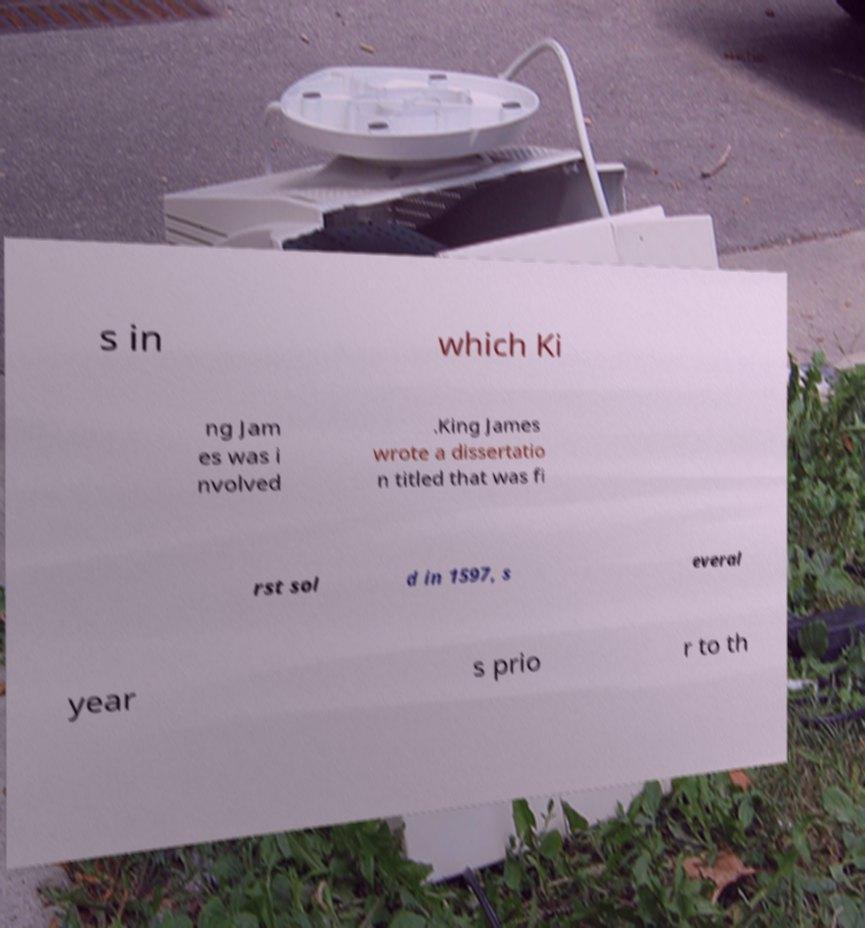I need the written content from this picture converted into text. Can you do that? s in which Ki ng Jam es was i nvolved .King James wrote a dissertatio n titled that was fi rst sol d in 1597, s everal year s prio r to th 